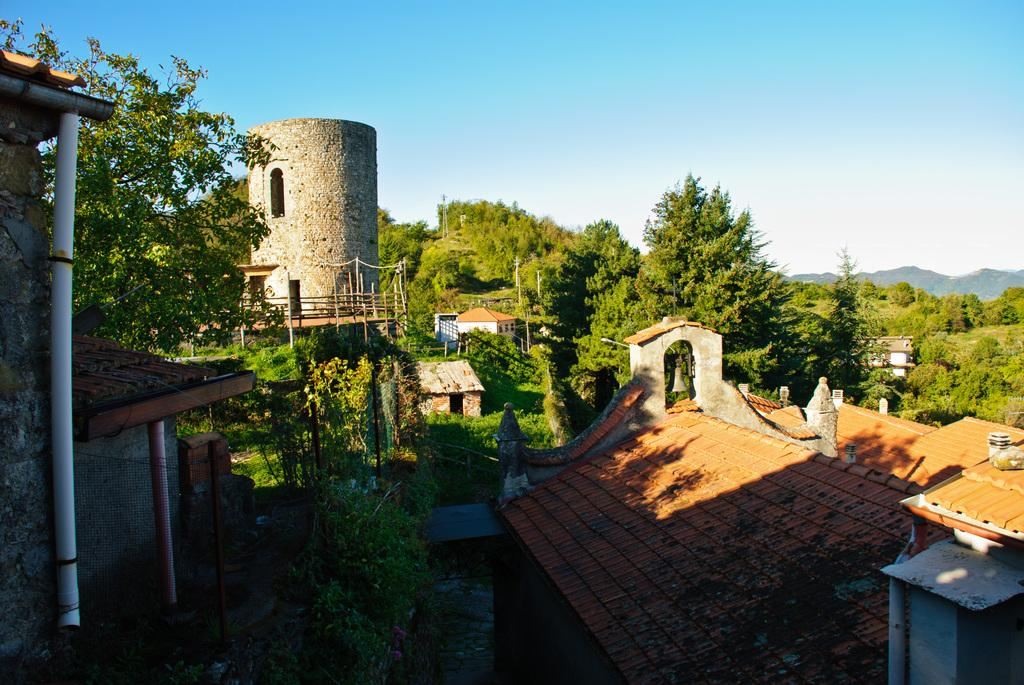What type of structures can be seen in the image? There are buildings in the image. What architectural feature is present in the image? There is net fencing in the image. What type of vegetation is visible in the image? There are trees in the image. What type of barrier can be seen in the image? There is railing in the image. What natural landform is visible in the image? There are mountains in the image. What object can be seen hanging in the image? There is a bell in the image. What part of the natural environment is visible in the image? The sky is visible in the image. Can you tell me how many cacti are visible in the image? There are no cacti present in the image. What type of vehicle is driving through the image? There is no vehicle visible in the image. 